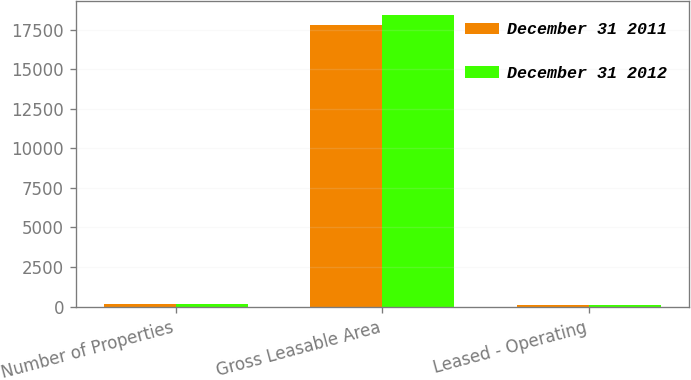Convert chart to OTSL. <chart><loc_0><loc_0><loc_500><loc_500><stacked_bar_chart><ecel><fcel>Number of Properties<fcel>Gross Leasable Area<fcel>Leased - Operating<nl><fcel>December 31 2011<fcel>144<fcel>17762<fcel>95.2<nl><fcel>December 31 2012<fcel>147<fcel>18399<fcel>94.8<nl></chart> 